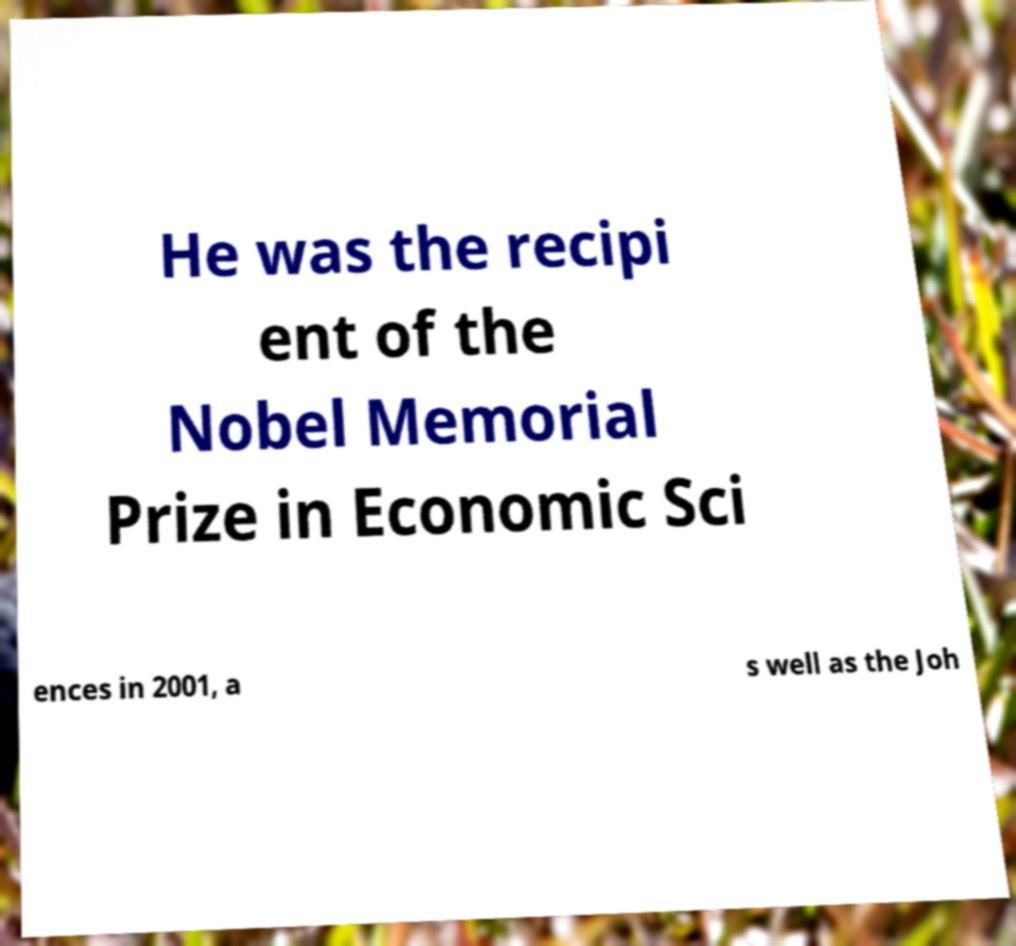What messages or text are displayed in this image? I need them in a readable, typed format. He was the recipi ent of the Nobel Memorial Prize in Economic Sci ences in 2001, a s well as the Joh 